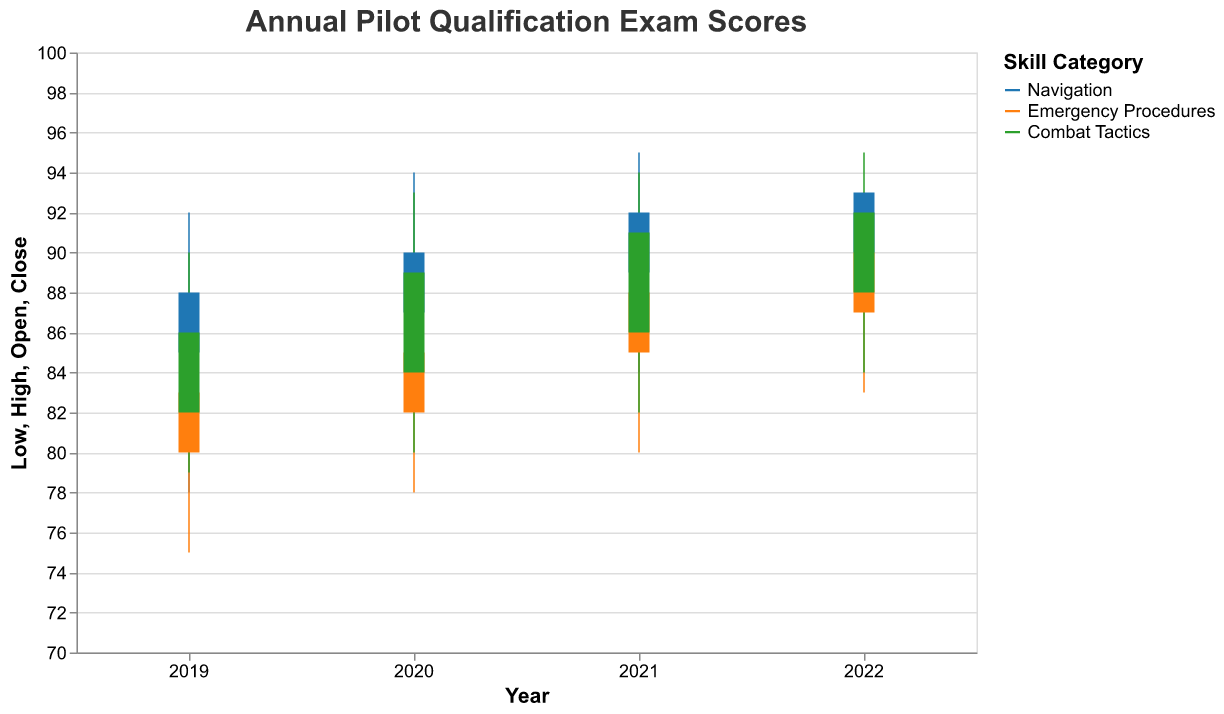What's the highest score in the Emergency Procedures category in 2021? The figure shows the high score for the Emergency Procedures category in 2021 as the top boundary (High value) within the bar for that year and category. The highest score indicated is 91.
Answer: 91 Which category had the highest closing score in 2022? Look at the "Close" value for each category in 2022. The Close value for Navigation is 93, Emergency Procedures is 90, and Combat Tactics is 92. The highest score among these is 93 in the Navigation category.
Answer: Navigation What's the range of scores for Combat Tactics in 2020? The range is the difference between the High and Low scores. For Combat Tactics in 2020, it is 93 - 80 = 13.
Answer: 13 In which year and category was the lowest score recorded, and what was it? The lowest recorded score is indicated by the Low value. In this case, the lowest score is 75 in Emergency Procedures in 2019.
Answer: 75 in Emergency Procedures in 2019 Compare the opening scores for Emergency Procedures in 2019 and 2022. Which one is higher and by how much? Refer to the Open values for Emergency Procedures in 2019 and 2022. The 2019 opening score is 80 and the 2022 opening score is 87. The difference is 87 - 80 = 7.
Answer: 2022 by 7 points What is the median closing score of Combat Tactics from 2019 to 2022? List the closing scores for Combat Tactics: 86, 89, 91, and 92. The median of these values is (89 + 91) / 2 = 90.
Answer: 90 How did the high scores in Navigation evolve from 2019 to 2022? Look at the high scores for Navigation for each year: 92 in 2019, 94 in 2020, 95 in 2021, and 96 in 2022. The scores consistently increased each year.
Answer: Increased every year Compare the range of scores (High - Low) for Navigation in 2019 and 2022. Calculate the range for each year: In 2019, it is 92 - 78 = 14. In 2022, it is 96 - 86 = 10. The range for 2019 is higher by 4 points.
Answer: 2019 by 4 points Which skill category showed the most improvement in closing scores from 2019 to 2022? Compare the Close values between 2019 and 2022 for each category: Navigation improved by 93-88=5, Emergency Procedures by 90-83=7, and Combat Tactics by 92-86=6. Emergency Procedures showed the most improvement.
Answer: Emergency Procedures 